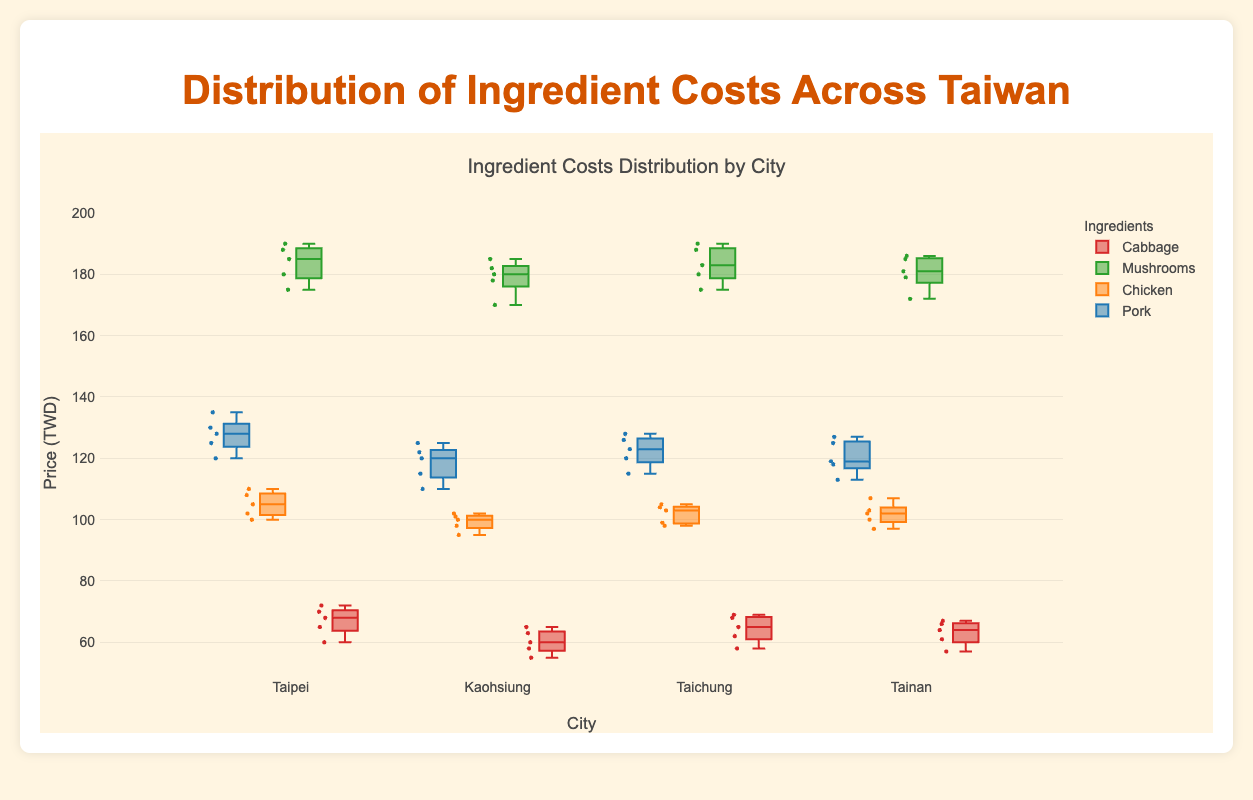What is the title of the figure? The title of the figure is shown at the top and it reads "Ingredient Costs Distribution by City".
Answer: Ingredient Costs Distribution by City Which city shows the highest median cost for Mushrooms? To find this, look at the middle line within each box plot for Mushrooms across the cities. The highest median line for Mushrooms is in Taipei.
Answer: Taipei How does the minimum price of Cabbage in Taipei compare to the minimum price in Tainan? The minimum price for Cabbage is the lower whisker of the box plot. In Taipei, the minimum price is 60, while in Tainan, it is 57. So, the minimum price in Taipei is higher.
Answer: Higher What is the range of Chicken prices in Kaohsiung? The range is the difference between the highest and lowest values. In Kaohsiung, the box plot shows the highest value for Chicken is 102 and the lowest is 95. Therefore, the range is 102 - 95 = 7 TWD.
Answer: 7 TWD Which city has the greatest variation in Pork prices? The variation can be assessed by looking at the spread of the box plot (the interquartile range and whiskers). Taipei has the greatest spread for Pork prices compared to other cities.
Answer: Taipei For which ingredient do all cities show prices higher than 50 TWD? By scanning the box plots for each ingredient, all the plots for Mushrooms show prices that are higher than 50 TWD.
Answer: Mushrooms Which city displays the least variation for Cabbage costs? The city with the shortest box (interquartile range) and the shortest whiskers indicates the least variation. Tainan has the least variation for Cabbage costs as its box plot is the shortest.
Answer: Tainan How does the upper quartile of Chicken costs in Taichung compare to that in Tainan? The upper quartile corresponds to the top edge of the box in each plot. In Taichung, the upper quartile for Chicken is around 105, while in Tainan, it is slightly above 103. Thus, Taichung's upper quartile is higher.
Answer: Higher Which ingredient shows a significant overlap in price ranges across all cities? Look for box plots whose interquartile ranges and whiskers overlap significantly across cities. Chicken shows a significant overlap in price ranges across all cities.
Answer: Chicken What is the interquartile range of Pork prices in Tainan? The IQR is the difference between the upper quartile and lower quartile. For Tainan, the top edge of the Pork box is around 125 and the bottom edge is around 118, so the interquartile range is 125 - 118 = 7 TWD.
Answer: 7 TWD 